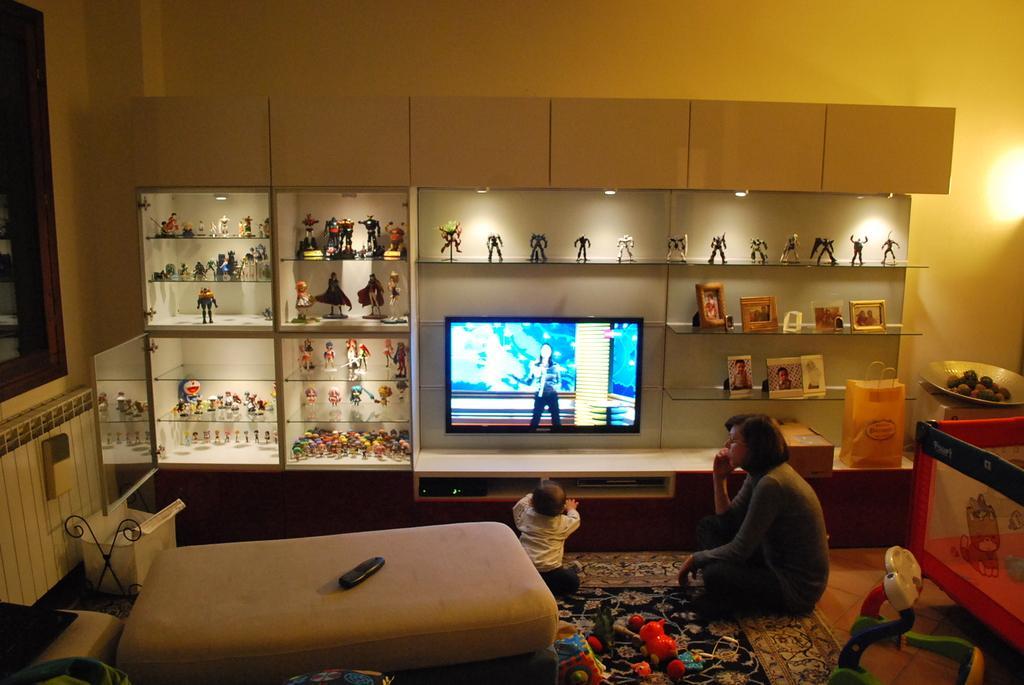Could you give a brief overview of what you see in this image? In the image we can see a woman and a baby sitting. They are wearing clothes, this is a television, carpet, floor, shelf, wall, remote, a bed and a light. 